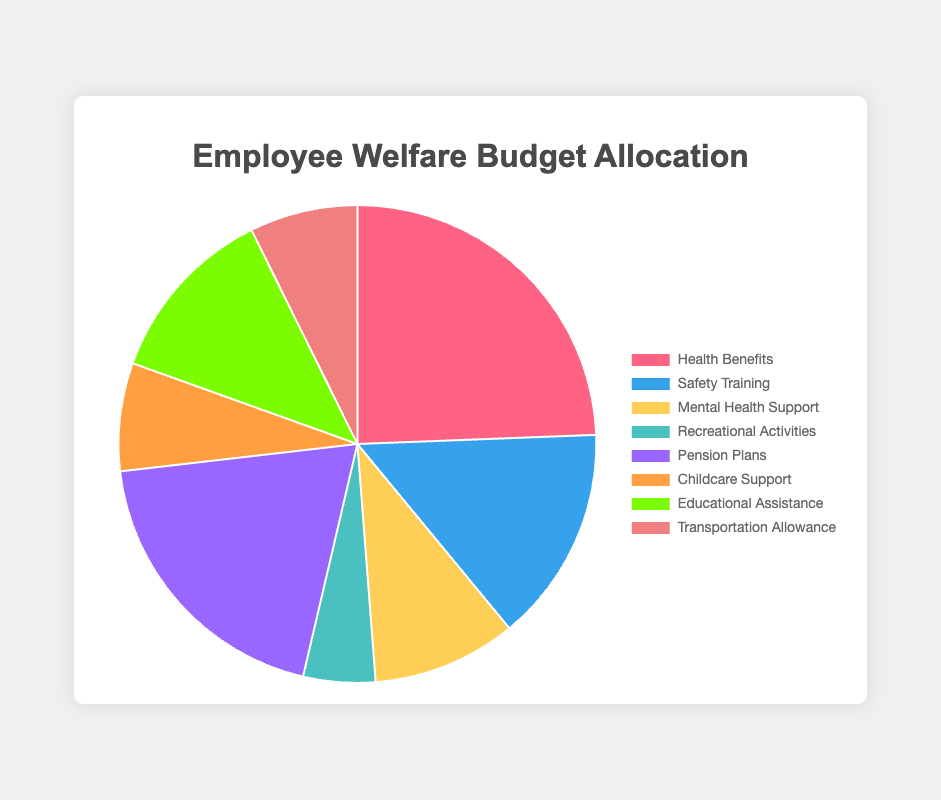Which category has the highest budget allocation in the pie chart? The slice representing Health Benefits is the largest in the pie chart with a 25% allocation.
Answer: Health Benefits Which two categories have equal budget allocations? The slices for Childcare Support and Transportation Allowance both allocate 7.5% of the budget.
Answer: Childcare Support and Transportation Allowance What is the combined budget percentage for Mental Health Support and Educational Assistance? Mental Health Support has 10%, and Educational Assistance has 12.5%. Adding these together gives 22.5%.
Answer: 22.5% Which category has the smallest budget allocation? The Recreational Activities slice is the smallest in the pie chart with a 5% allocation.
Answer: Recreational Activities How much larger is the Health Benefits allocation compared to Safety Training? Health Benefits is 25%, while Safety Training is 15%. The difference is 25% - 15% = 10%.
Answer: 10% If the categories Childcare Support and Transportation Allowance were combined, what would their total budget allocation be? Each category is allocated 7.5%, so combined they would have 7.5% + 7.5% = 15%.
Answer: 15% How does the budget allocation for Pension Plans compare to Educational Assistance? Pension Plans allocate 20%, while Educational Assistance allocates 12.5%. Pension Plans have a higher allocation by 20% - 12.5% = 7.5%.
Answer: 7.5% What is the average budget allocation percentage across all categories? Summing up all percentages gives 100%. There are 8 categories. The average allocation is 100% / 8 = 12.5%.
Answer: 12.5% What percentage of the budget is allocated to categories related to health and safety combined (Health Benefits and Safety Training)? Health Benefits allocate 25%, and Safety Training allocates 15%. Adding these together gives 25% + 15% = 40%.
Answer: 40% What is the difference in budget allocation between the Mental Health Support and Recreational Activities categories? Mental Health Support has 10%, and Recreational Activities have 5%. The difference is 10% - 5% = 5%.
Answer: 5% 